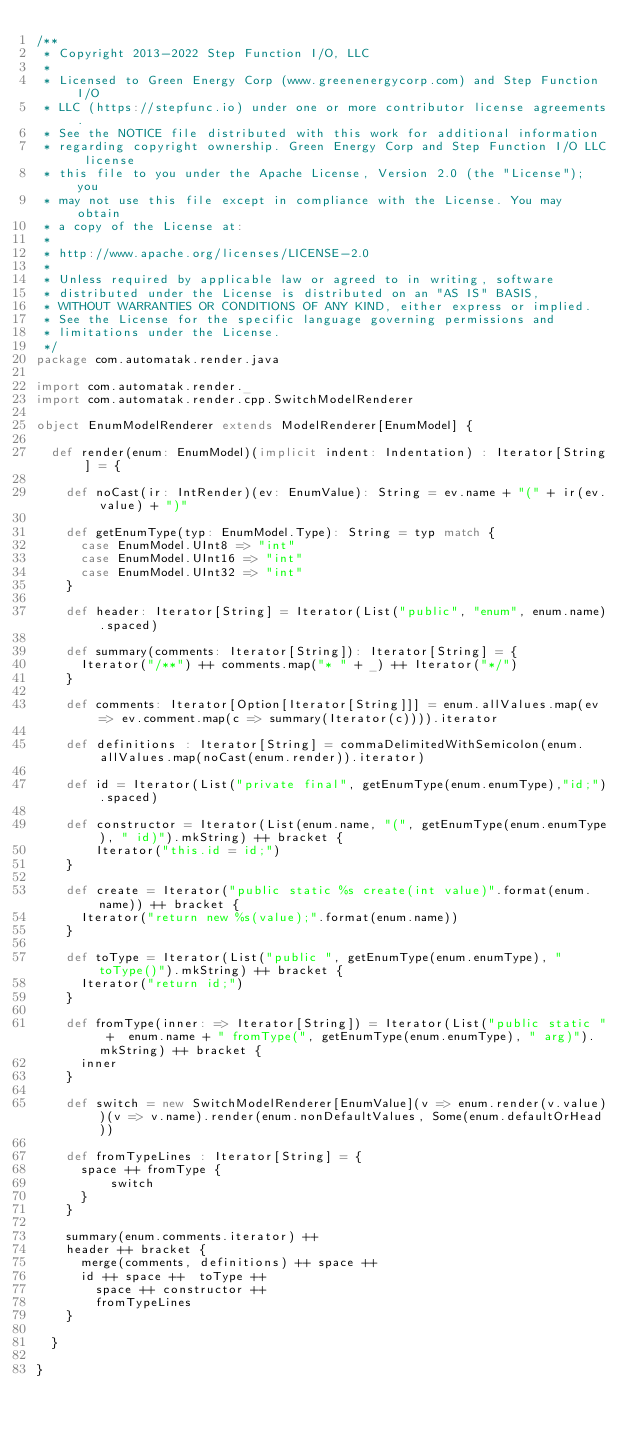Convert code to text. <code><loc_0><loc_0><loc_500><loc_500><_Scala_>/**
 * Copyright 2013-2022 Step Function I/O, LLC
 *
 * Licensed to Green Energy Corp (www.greenenergycorp.com) and Step Function I/O
 * LLC (https://stepfunc.io) under one or more contributor license agreements.
 * See the NOTICE file distributed with this work for additional information
 * regarding copyright ownership. Green Energy Corp and Step Function I/O LLC license
 * this file to you under the Apache License, Version 2.0 (the "License"); you
 * may not use this file except in compliance with the License. You may obtain
 * a copy of the License at:
 *
 * http://www.apache.org/licenses/LICENSE-2.0
 *
 * Unless required by applicable law or agreed to in writing, software
 * distributed under the License is distributed on an "AS IS" BASIS,
 * WITHOUT WARRANTIES OR CONDITIONS OF ANY KIND, either express or implied.
 * See the License for the specific language governing permissions and
 * limitations under the License.
 */
package com.automatak.render.java

import com.automatak.render._
import com.automatak.render.cpp.SwitchModelRenderer

object EnumModelRenderer extends ModelRenderer[EnumModel] {

  def render(enum: EnumModel)(implicit indent: Indentation) : Iterator[String] = {

    def noCast(ir: IntRender)(ev: EnumValue): String = ev.name + "(" + ir(ev.value) + ")"

    def getEnumType(typ: EnumModel.Type): String = typ match {
      case EnumModel.UInt8 => "int"
      case EnumModel.UInt16 => "int"
      case EnumModel.UInt32 => "int"
    }

    def header: Iterator[String] = Iterator(List("public", "enum", enum.name).spaced)

    def summary(comments: Iterator[String]): Iterator[String] = {
      Iterator("/**") ++ comments.map("* " + _) ++ Iterator("*/")
    }

    def comments: Iterator[Option[Iterator[String]]] = enum.allValues.map(ev => ev.comment.map(c => summary(Iterator(c)))).iterator

    def definitions : Iterator[String] = commaDelimitedWithSemicolon(enum.allValues.map(noCast(enum.render)).iterator)

    def id = Iterator(List("private final", getEnumType(enum.enumType),"id;").spaced)

    def constructor = Iterator(List(enum.name, "(", getEnumType(enum.enumType), " id)").mkString) ++ bracket {
        Iterator("this.id = id;")
    }

    def create = Iterator("public static %s create(int value)".format(enum.name)) ++ bracket {
      Iterator("return new %s(value);".format(enum.name))
    }

    def toType = Iterator(List("public ", getEnumType(enum.enumType), " toType()").mkString) ++ bracket {
      Iterator("return id;")
    }

    def fromType(inner: => Iterator[String]) = Iterator(List("public static " +  enum.name + " fromType(", getEnumType(enum.enumType), " arg)").mkString) ++ bracket {
      inner
    }

    def switch = new SwitchModelRenderer[EnumValue](v => enum.render(v.value))(v => v.name).render(enum.nonDefaultValues, Some(enum.defaultOrHead))

    def fromTypeLines : Iterator[String] = {
      space ++ fromType {
          switch
      }
    }

    summary(enum.comments.iterator) ++
    header ++ bracket {
      merge(comments, definitions) ++ space ++
      id ++ space ++  toType ++
        space ++ constructor ++
        fromTypeLines
    }

  }

}
</code> 